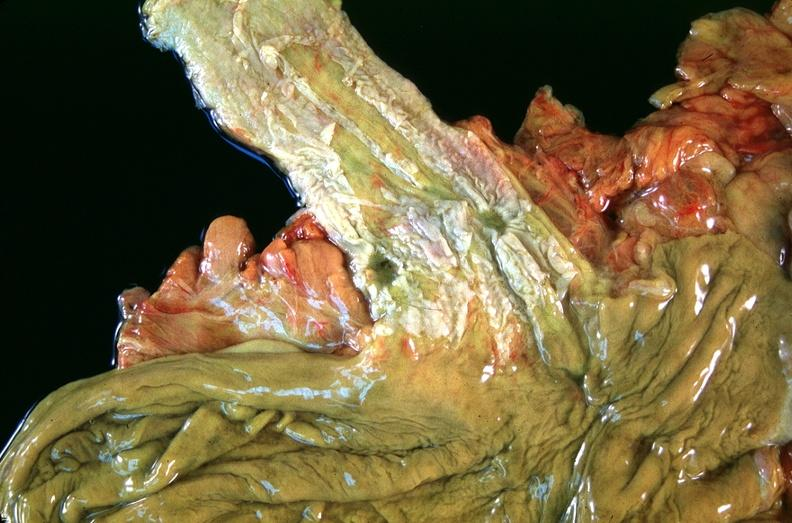s gastrointestinal present?
Answer the question using a single word or phrase. Yes 